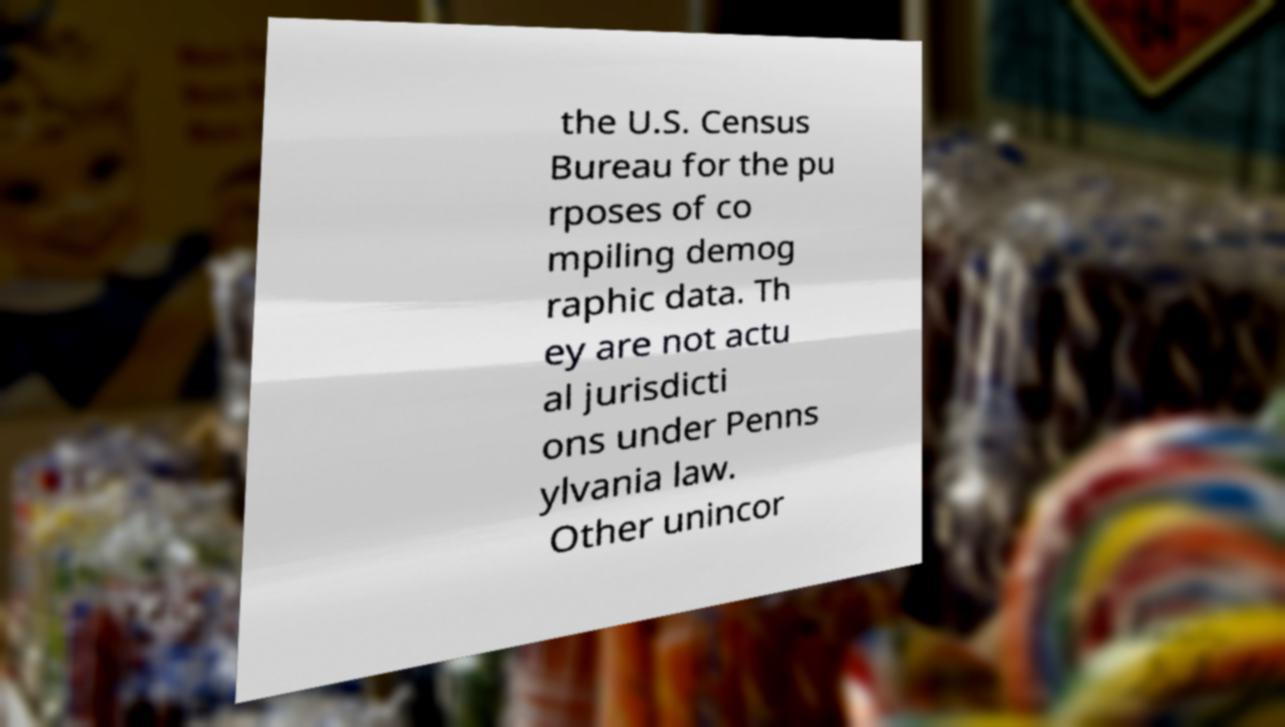What messages or text are displayed in this image? I need them in a readable, typed format. the U.S. Census Bureau for the pu rposes of co mpiling demog raphic data. Th ey are not actu al jurisdicti ons under Penns ylvania law. Other unincor 